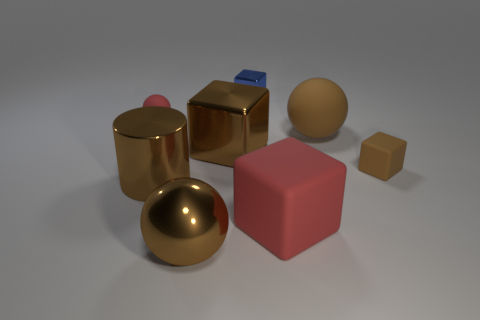Add 1 small blue metallic things. How many objects exist? 9 Subtract all balls. How many objects are left? 5 Subtract all big purple metal balls. Subtract all brown cylinders. How many objects are left? 7 Add 4 matte cubes. How many matte cubes are left? 6 Add 8 red balls. How many red balls exist? 9 Subtract 0 yellow spheres. How many objects are left? 8 